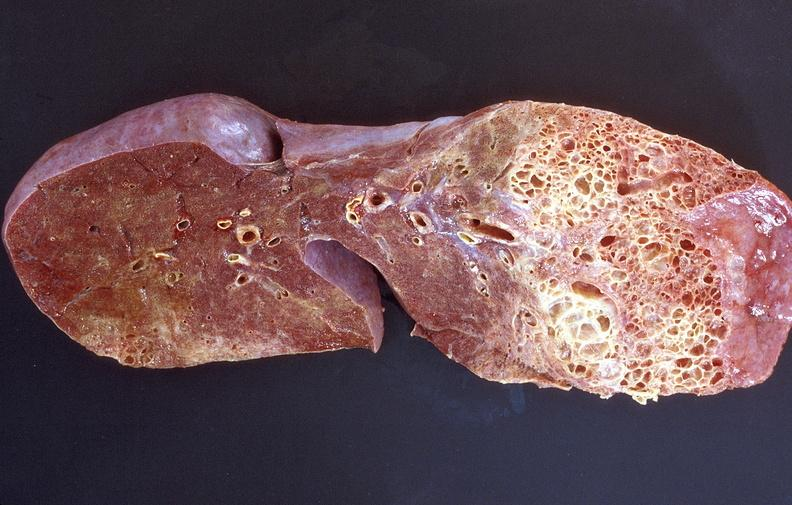what does this image show?
Answer the question using a single word or phrase. Lung fibrosis 